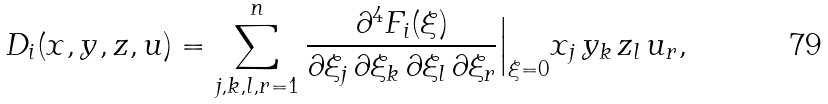Convert formula to latex. <formula><loc_0><loc_0><loc_500><loc_500>D _ { i } ( { x } , { y } , { z } , { u } ) = \sum _ { j , k , l , r = 1 } ^ { n } \frac { \partial ^ { 4 } F _ { i } ( \xi ) } { \partial \xi _ { j } \, \partial \xi _ { k } \, \partial \xi _ { l } \, \partial \xi _ { r } } \Big | _ { \xi = 0 } x _ { j } \, y _ { k } \, z _ { l } \, u _ { r } ,</formula> 